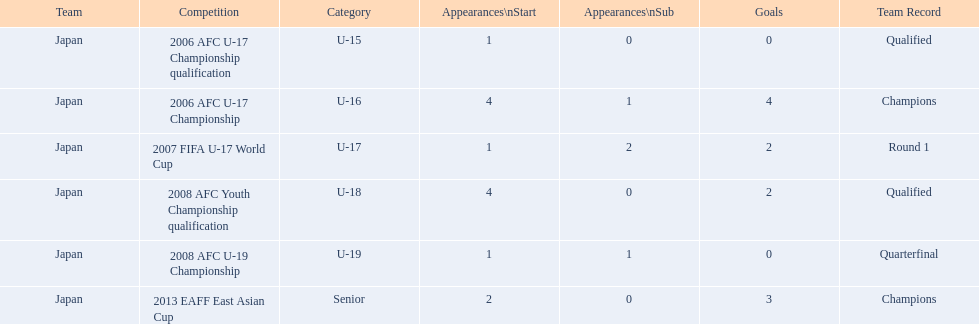What are the competitions yoichiro kakitani has been involved in? 2006 AFC U-17 Championship qualification, 2006 AFC U-17 Championship, 2007 FIFA U-17 World Cup, 2008 AFC Youth Championship qualification, 2008 AFC U-19 Championship, 2013 EAFF East Asian Cup. How many starts did he have in each of those competitions? 1, 4, 1, 4, 1, 2. How many goals did he score during them? 0, 4, 2, 2, 0, 3. In which competition did he register the highest number of starts and goals? 2006 AFC U-17 Championship. 